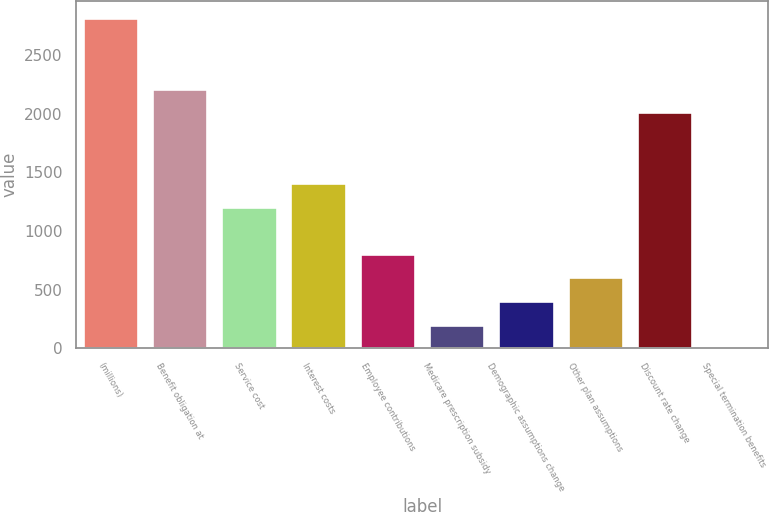<chart> <loc_0><loc_0><loc_500><loc_500><bar_chart><fcel>(millions)<fcel>Benefit obligation at<fcel>Service cost<fcel>Interest costs<fcel>Employee contributions<fcel>Medicare prescription subsidy<fcel>Demographic assumptions change<fcel>Other plan assumptions<fcel>Discount rate change<fcel>Special termination benefits<nl><fcel>2816.76<fcel>2213.19<fcel>1207.24<fcel>1408.43<fcel>804.86<fcel>201.29<fcel>402.48<fcel>603.67<fcel>2012<fcel>0.1<nl></chart> 